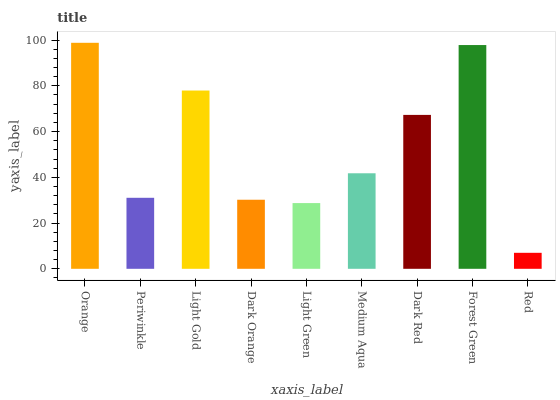Is Red the minimum?
Answer yes or no. Yes. Is Orange the maximum?
Answer yes or no. Yes. Is Periwinkle the minimum?
Answer yes or no. No. Is Periwinkle the maximum?
Answer yes or no. No. Is Orange greater than Periwinkle?
Answer yes or no. Yes. Is Periwinkle less than Orange?
Answer yes or no. Yes. Is Periwinkle greater than Orange?
Answer yes or no. No. Is Orange less than Periwinkle?
Answer yes or no. No. Is Medium Aqua the high median?
Answer yes or no. Yes. Is Medium Aqua the low median?
Answer yes or no. Yes. Is Dark Orange the high median?
Answer yes or no. No. Is Periwinkle the low median?
Answer yes or no. No. 